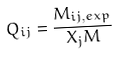Convert formula to latex. <formula><loc_0><loc_0><loc_500><loc_500>Q _ { i j } = \frac { M _ { i j , e x p } } { X _ { j } M }</formula> 